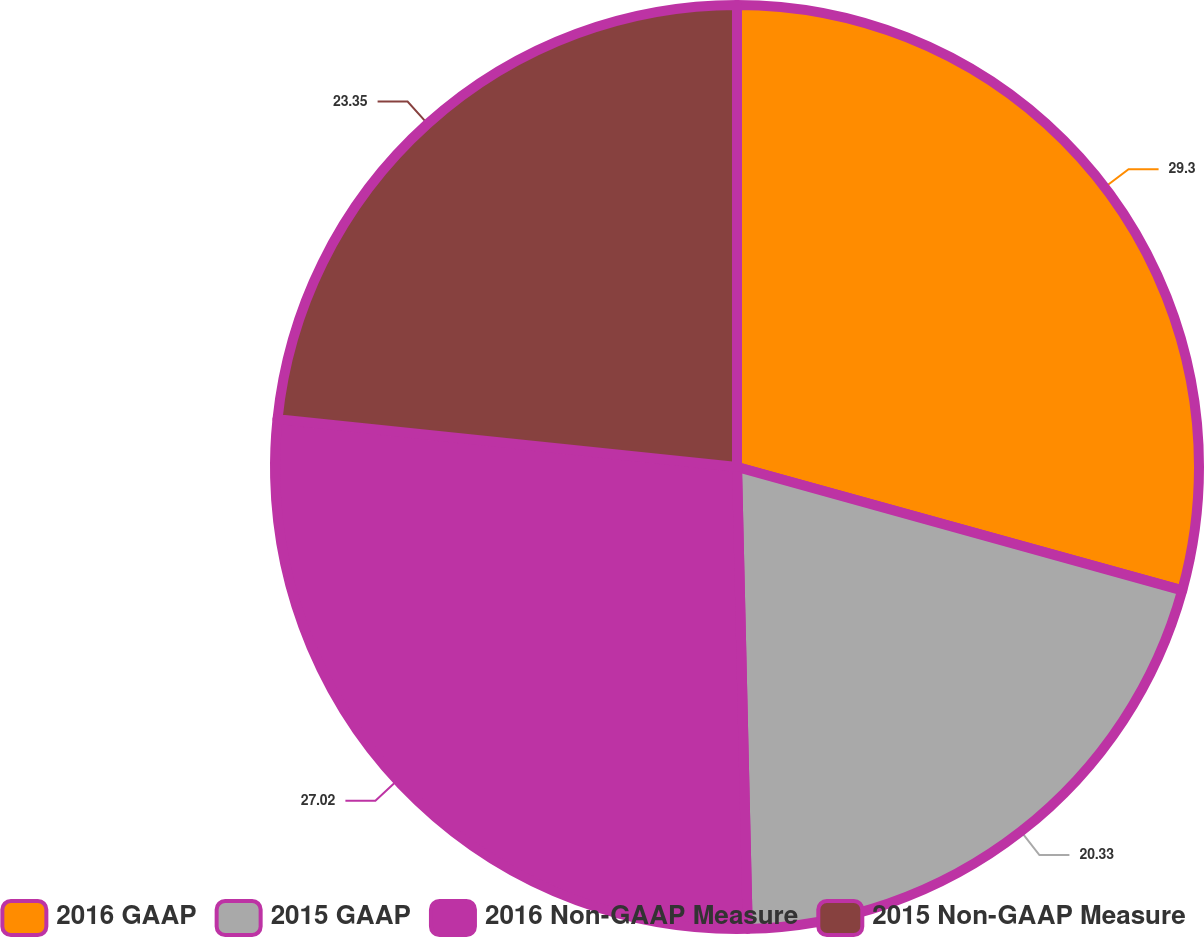<chart> <loc_0><loc_0><loc_500><loc_500><pie_chart><fcel>2016 GAAP<fcel>2015 GAAP<fcel>2016 Non-GAAP Measure<fcel>2015 Non-GAAP Measure<nl><fcel>29.3%<fcel>20.33%<fcel>27.02%<fcel>23.35%<nl></chart> 